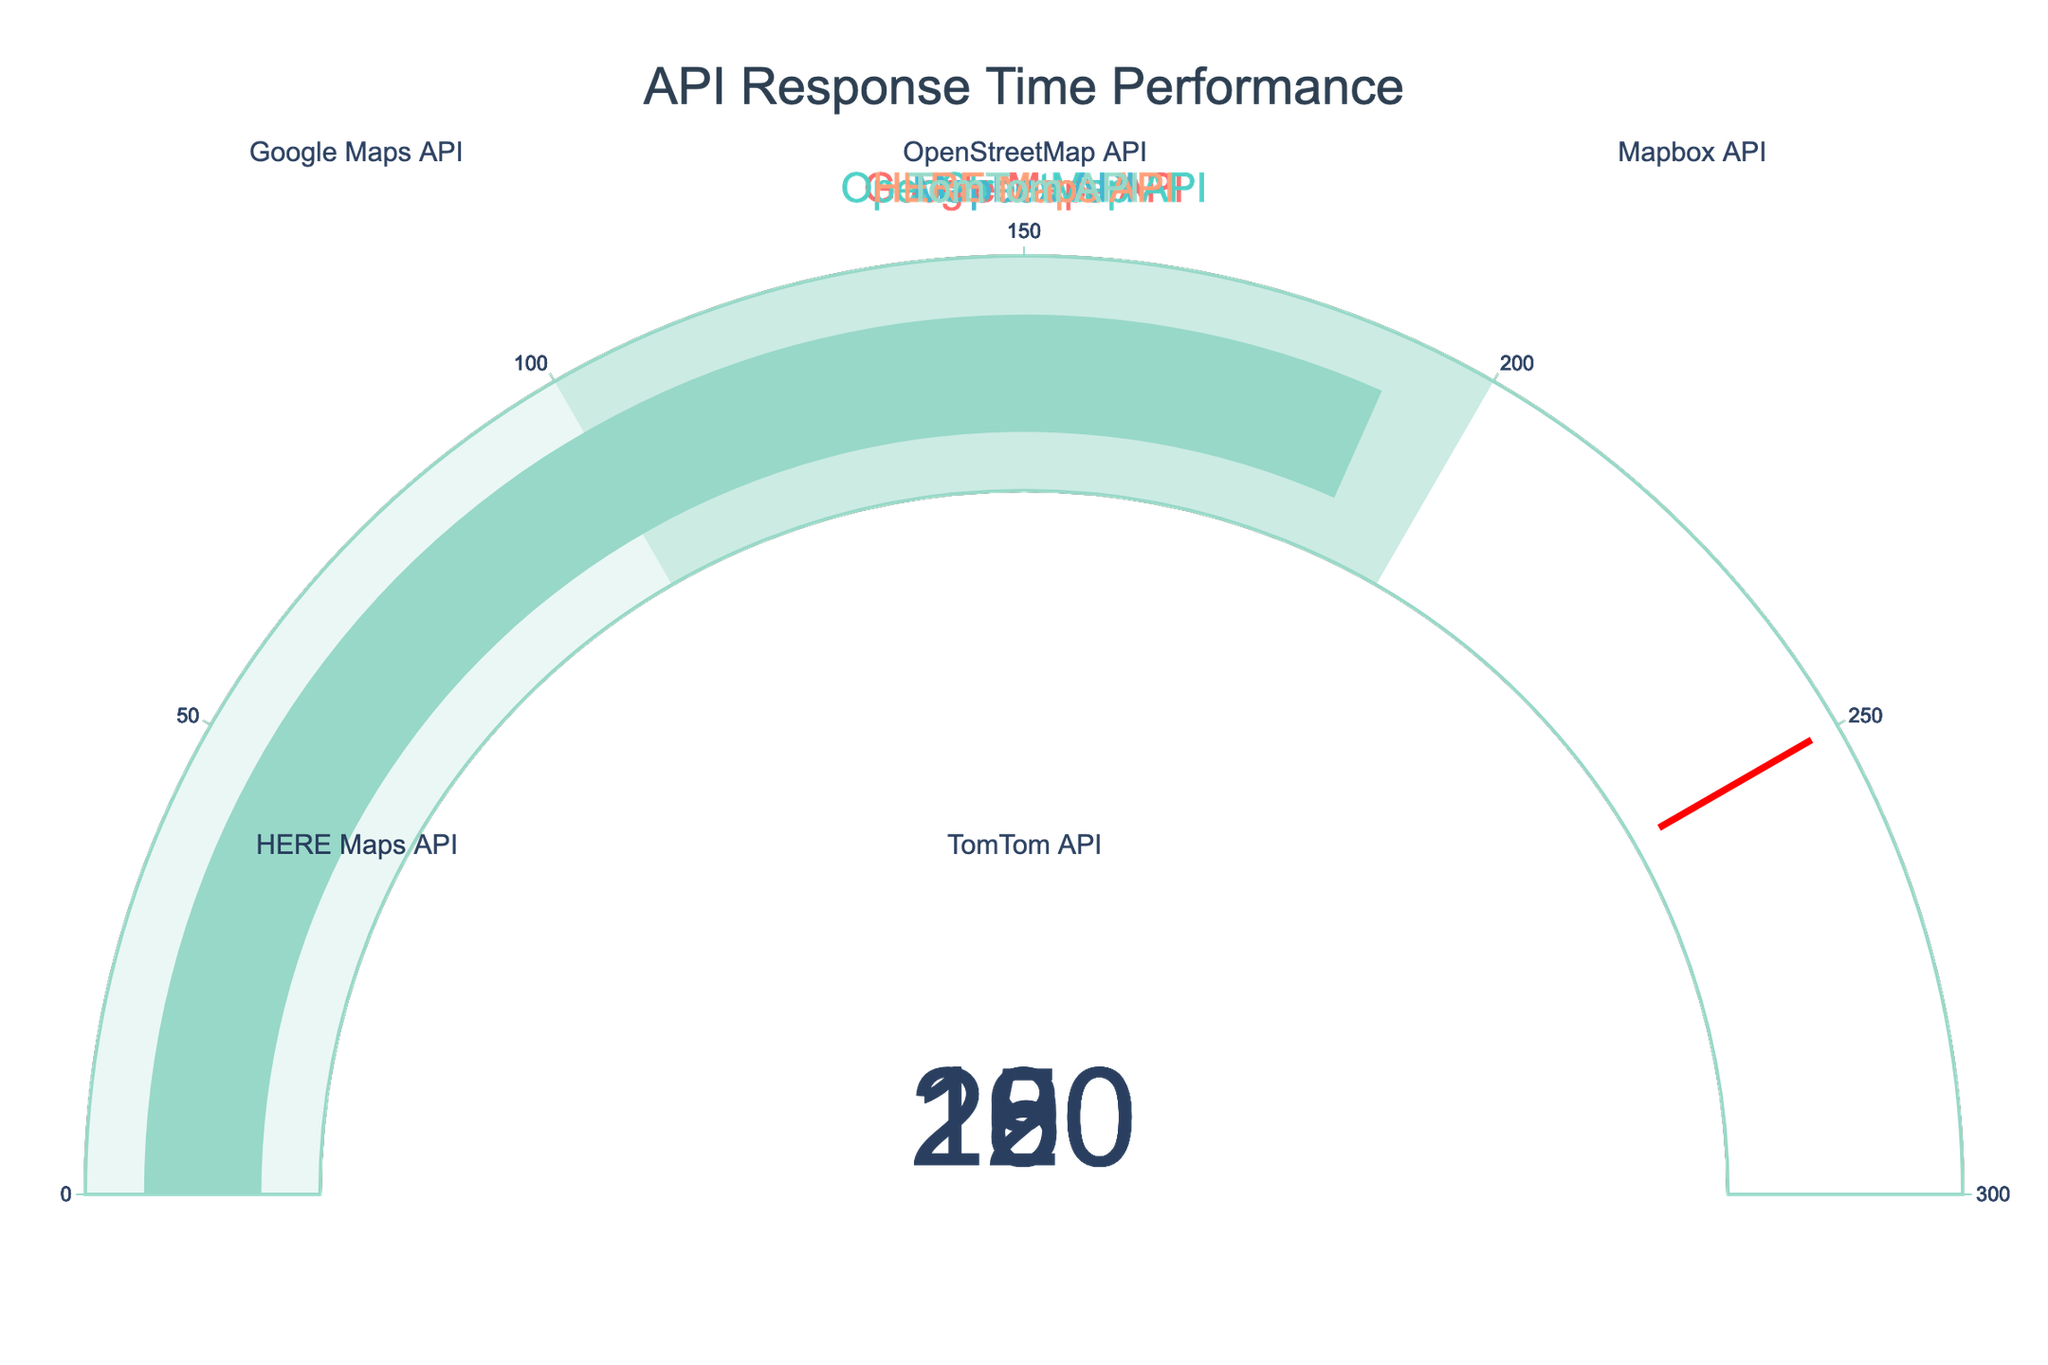How many APIs are shown in the figure? Count the number of gauges displayed in the figure. Each gauge represents one API. There are 5 gauges.
Answer: 5 What is the title of the figure? The title of the figure is displayed at the top center of the chart. It reads "API Response Time Performance".
Answer: API Response Time Performance Which API has the highest response time? Look at the values on the gauges and identify the highest one. The HERE Maps API shows the highest response time of 220ms.
Answer: HERE Maps API What is the range of the gauges on the chart? The range of the gauges is represented on the scale of each gauge. All gauges have a range from 0 to 300ms.
Answer: 0 to 300ms What is the primary color of the gauge for the Google Maps API? Observe the color of the gauge bar associated with the Google Maps API gauge. It is shown as red.
Answer: Red What is the difference in response time between the Mapbox API and the TomTom API? Subtract the response time of the Mapbox API from the response time of the TomTom API. 190ms (TomTom) - 180ms (Mapbox) = 10ms.
Answer: 10ms Which APIs have a response time greater than 200ms? Look at the response times displayed on each gauge and identify those higher than 200ms. The HERE Maps API with 220ms fits this criterion.
Answer: HERE Maps API What is the average response time of all the APIs shown? Sum the response times of all the APIs and divide by the number of APIs: (150ms + 200ms + 180ms + 220ms + 190ms) / 5 = 188ms.
Answer: 188ms Which API's gauge is closest to hitting the threshold value of 250ms? Examine the gauges and identify which response time is nearest to the threshold of 250ms without exceeding it. HERE Maps API with 220ms is the closest.
Answer: HERE Maps API What is the combined response time of Google Maps API and OpenStreetMap API? Add the response times of Google Maps API and OpenStreetMap API together: 150ms + 200ms = 350ms.
Answer: 350ms 